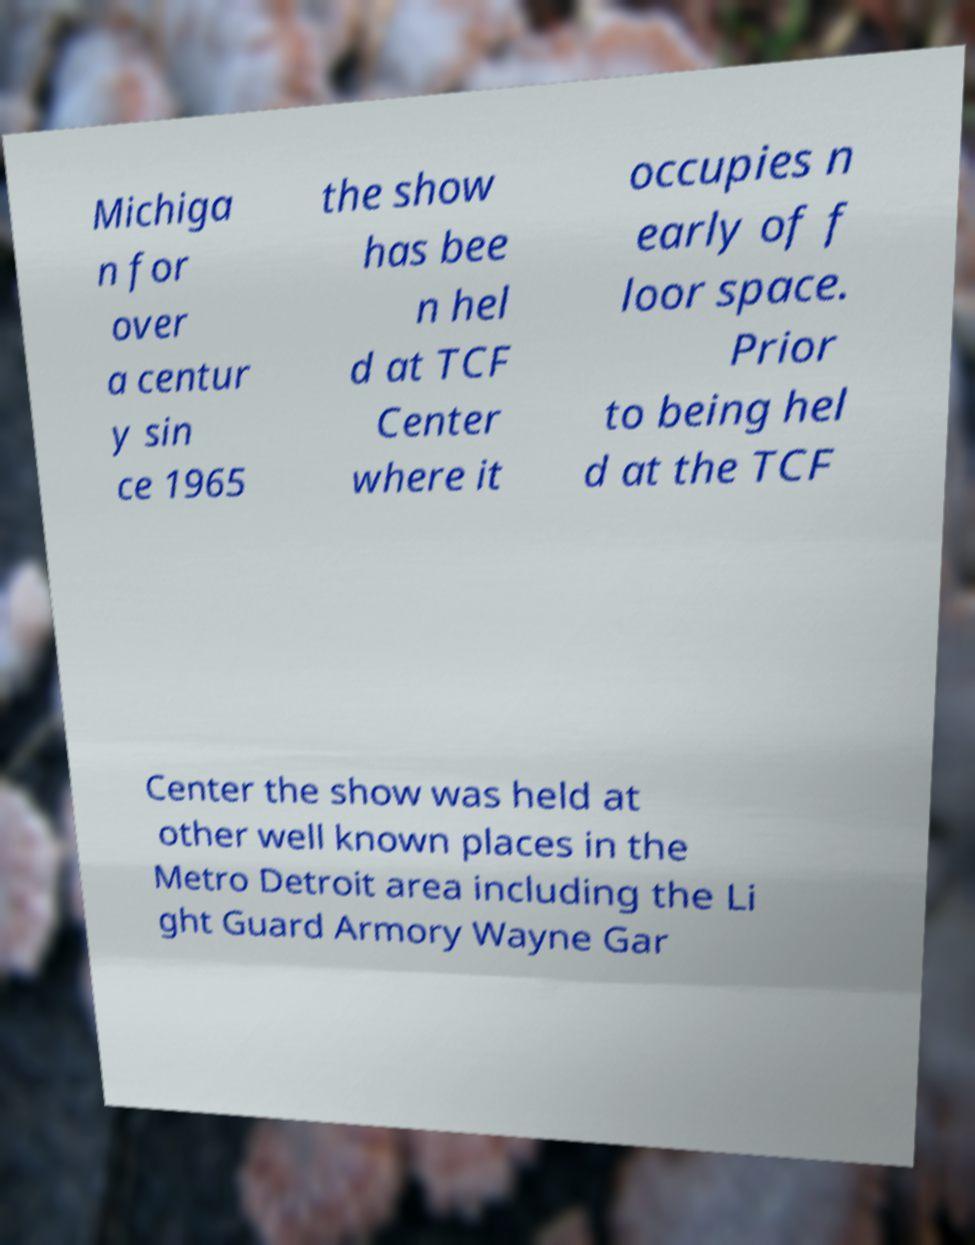Please identify and transcribe the text found in this image. Michiga n for over a centur y sin ce 1965 the show has bee n hel d at TCF Center where it occupies n early of f loor space. Prior to being hel d at the TCF Center the show was held at other well known places in the Metro Detroit area including the Li ght Guard Armory Wayne Gar 